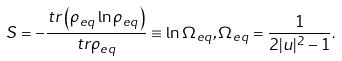Convert formula to latex. <formula><loc_0><loc_0><loc_500><loc_500>S = - \frac { t r \left ( \rho _ { e q } \ln \rho _ { e q } \right ) } { t r \rho _ { e q } } \equiv \ln \Omega _ { e q } , \Omega _ { e q } = \frac { 1 } { 2 | u | ^ { 2 } - 1 } .</formula> 